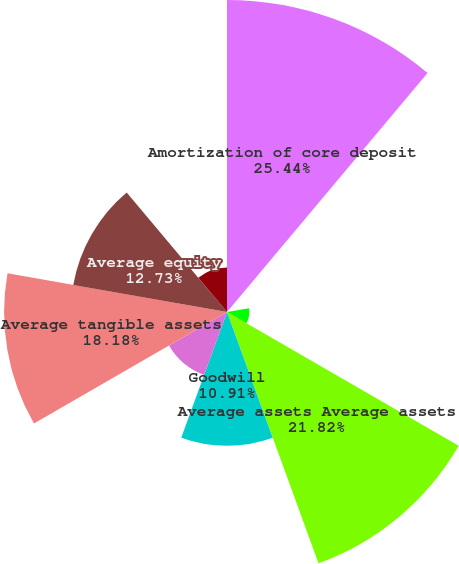<chart> <loc_0><loc_0><loc_500><loc_500><pie_chart><fcel>Amortization of core deposit<fcel>Diluted earnings per common<fcel>Diluted net operating earnings<fcel>Average assets Average assets<fcel>Goodwill<fcel>Core deposit and other<fcel>Average tangible assets<fcel>Average equity<fcel>Deferred taxes<nl><fcel>25.45%<fcel>0.0%<fcel>1.82%<fcel>21.82%<fcel>10.91%<fcel>5.46%<fcel>18.18%<fcel>12.73%<fcel>3.64%<nl></chart> 